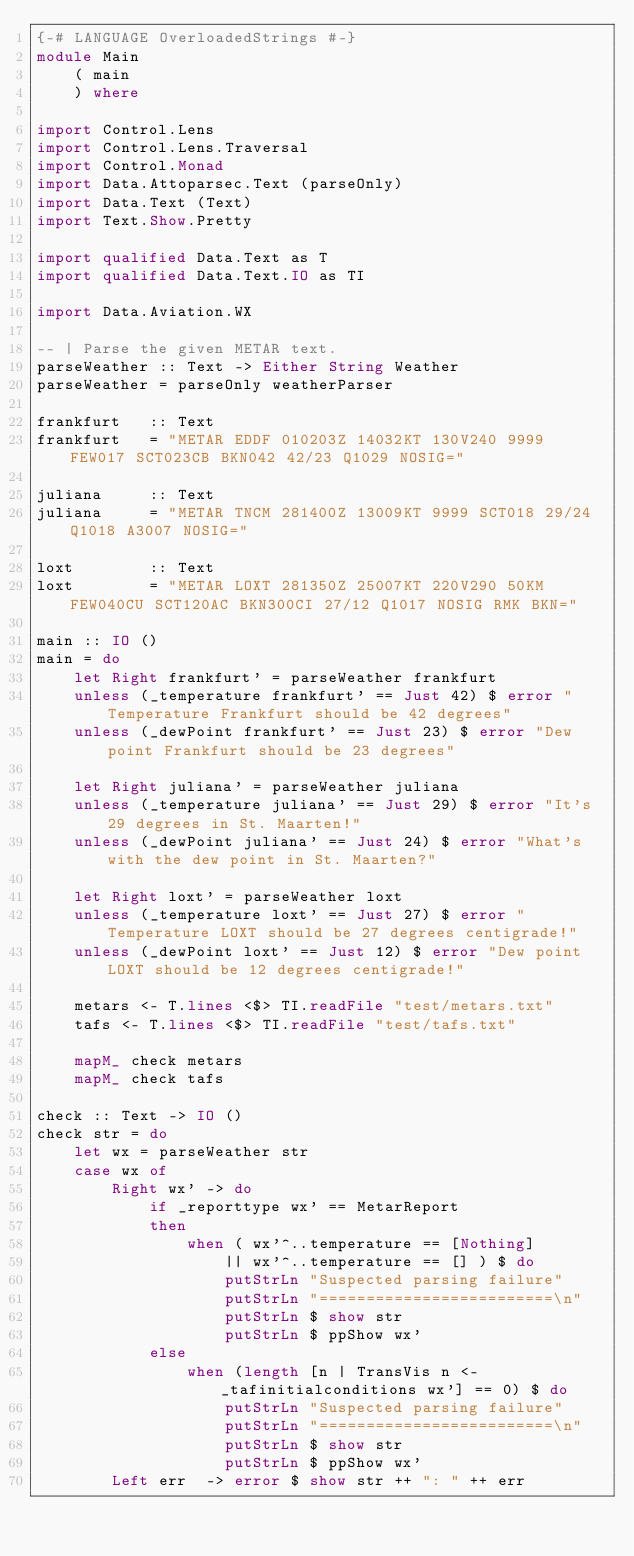<code> <loc_0><loc_0><loc_500><loc_500><_Haskell_>{-# LANGUAGE OverloadedStrings #-}
module Main
    ( main
    ) where

import Control.Lens
import Control.Lens.Traversal
import Control.Monad
import Data.Attoparsec.Text (parseOnly)
import Data.Text (Text)
import Text.Show.Pretty

import qualified Data.Text as T
import qualified Data.Text.IO as TI

import Data.Aviation.WX

-- | Parse the given METAR text.
parseWeather :: Text -> Either String Weather
parseWeather = parseOnly weatherParser

frankfurt   :: Text
frankfurt   = "METAR EDDF 010203Z 14032KT 130V240 9999 FEW017 SCT023CB BKN042 42/23 Q1029 NOSIG="

juliana     :: Text
juliana     = "METAR TNCM 281400Z 13009KT 9999 SCT018 29/24 Q1018 A3007 NOSIG="

loxt        :: Text
loxt        = "METAR LOXT 281350Z 25007KT 220V290 50KM FEW040CU SCT120AC BKN300CI 27/12 Q1017 NOSIG RMK BKN="

main :: IO ()
main = do
    let Right frankfurt' = parseWeather frankfurt
    unless (_temperature frankfurt' == Just 42) $ error "Temperature Frankfurt should be 42 degrees"
    unless (_dewPoint frankfurt' == Just 23) $ error "Dew point Frankfurt should be 23 degrees"

    let Right juliana' = parseWeather juliana
    unless (_temperature juliana' == Just 29) $ error "It's 29 degrees in St. Maarten!"
    unless (_dewPoint juliana' == Just 24) $ error "What's with the dew point in St. Maarten?"

    let Right loxt' = parseWeather loxt
    unless (_temperature loxt' == Just 27) $ error "Temperature LOXT should be 27 degrees centigrade!"
    unless (_dewPoint loxt' == Just 12) $ error "Dew point LOXT should be 12 degrees centigrade!"

    metars <- T.lines <$> TI.readFile "test/metars.txt"
    tafs <- T.lines <$> TI.readFile "test/tafs.txt"

    mapM_ check metars
    mapM_ check tafs

check :: Text -> IO ()
check str = do
    let wx = parseWeather str
    case wx of
        Right wx' -> do
            if _reporttype wx' == MetarReport
            then
                when ( wx'^..temperature == [Nothing]
                    || wx'^..temperature == [] ) $ do
                    putStrLn "Suspected parsing failure"
                    putStrLn "=========================\n"
                    putStrLn $ show str
                    putStrLn $ ppShow wx'
            else
                when (length [n | TransVis n <- _tafinitialconditions wx'] == 0) $ do
                    putStrLn "Suspected parsing failure"
                    putStrLn "=========================\n"
                    putStrLn $ show str
                    putStrLn $ ppShow wx'
        Left err  -> error $ show str ++ ": " ++ err
</code> 